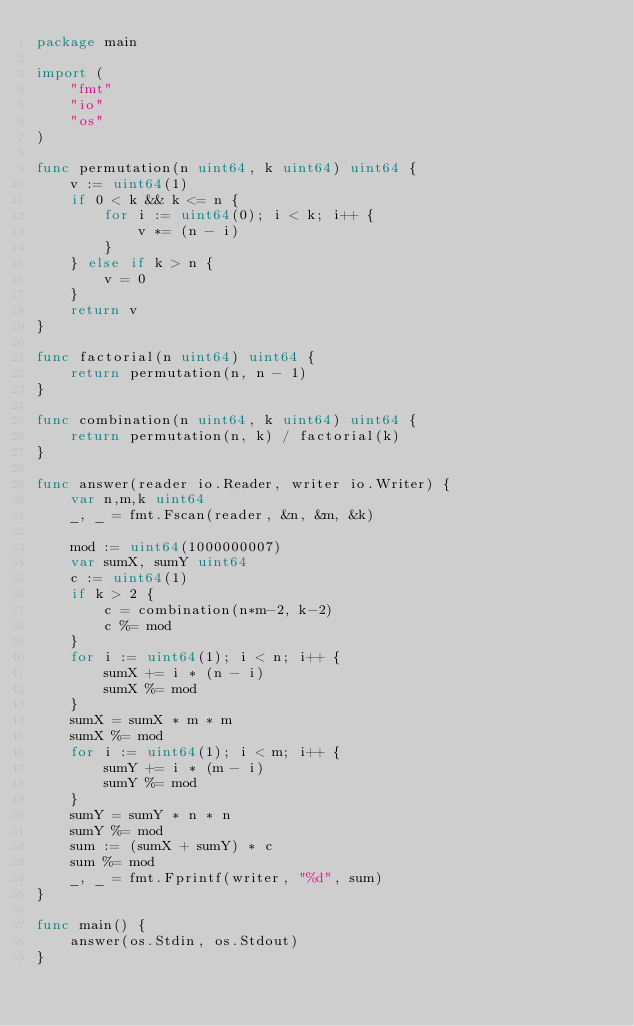Convert code to text. <code><loc_0><loc_0><loc_500><loc_500><_Go_>package main

import (
	"fmt"
	"io"
	"os"
)

func permutation(n uint64, k uint64) uint64 {
	v := uint64(1)
	if 0 < k && k <= n {
		for i := uint64(0); i < k; i++ {
			v *= (n - i)
		}
	} else if k > n {
		v = 0
	}
	return v
}

func factorial(n uint64) uint64 {
	return permutation(n, n - 1)
}

func combination(n uint64, k uint64) uint64 {
	return permutation(n, k) / factorial(k)
}

func answer(reader io.Reader, writer io.Writer) {
	var n,m,k uint64
	_, _ = fmt.Fscan(reader, &n, &m, &k)

	mod := uint64(1000000007)
	var sumX, sumY uint64
	c := uint64(1)
	if k > 2 {
		c = combination(n*m-2, k-2)
		c %= mod
	}
	for i := uint64(1); i < n; i++ {
		sumX += i * (n - i)
		sumX %= mod
	}
	sumX = sumX * m * m
	sumX %= mod
	for i := uint64(1); i < m; i++ {
		sumY += i * (m - i)
		sumY %= mod
	}
	sumY = sumY * n * n
	sumY %= mod
	sum := (sumX + sumY) * c
	sum %= mod
	_, _ = fmt.Fprintf(writer, "%d", sum)
}

func main() {
	answer(os.Stdin, os.Stdout)
}
</code> 